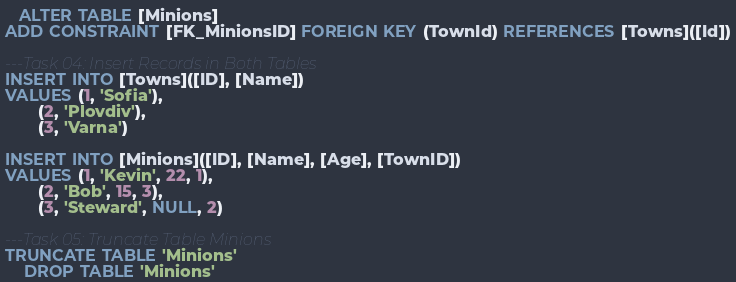<code> <loc_0><loc_0><loc_500><loc_500><_SQL_>   ALTER TABLE [Minions]
ADD CONSTRAINT [FK_MinionsID] FOREIGN KEY (TownId) REFERENCES [Towns]([Id])

---Task 04: Insert Records in Both Tables
INSERT INTO [Towns]([ID], [Name]) 
VALUES (1, 'Sofia'),
       (2, 'Plovdiv'),
       (3, 'Varna')

INSERT INTO [Minions]([ID], [Name], [Age], [TownID]) 
VALUES (1, 'Kevin', 22, 1),
       (2, 'Bob', 15, 3),
       (3, 'Steward', NULL, 2)

---Task 05: Truncate Table Minions
TRUNCATE TABLE 'Minions'
	DROP TABLE 'Minions'
</code> 